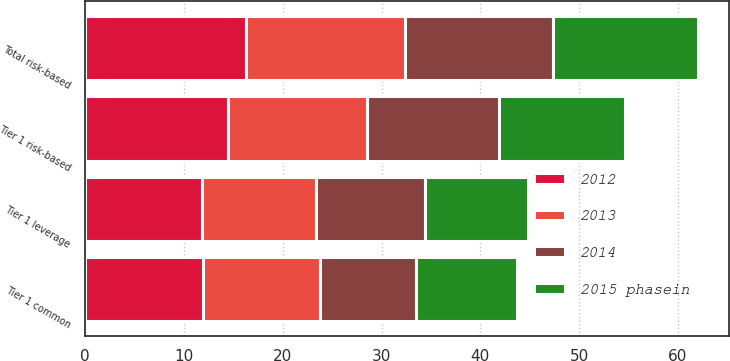Convert chart to OTSL. <chart><loc_0><loc_0><loc_500><loc_500><stacked_bar_chart><ecel><fcel>Tier 1 common<fcel>Tier 1 leverage<fcel>Tier 1 risk-based<fcel>Total risk-based<nl><fcel>2012<fcel>11.92<fcel>11.82<fcel>14.47<fcel>16.27<nl><fcel>2015 phasein<fcel>10.18<fcel>10.48<fcel>12.77<fcel>14.67<nl><fcel>2014<fcel>9.8<fcel>10.96<fcel>13.38<fcel>15.05<nl><fcel>2013<fcel>11.82<fcel>11.59<fcel>14.03<fcel>16.08<nl></chart> 